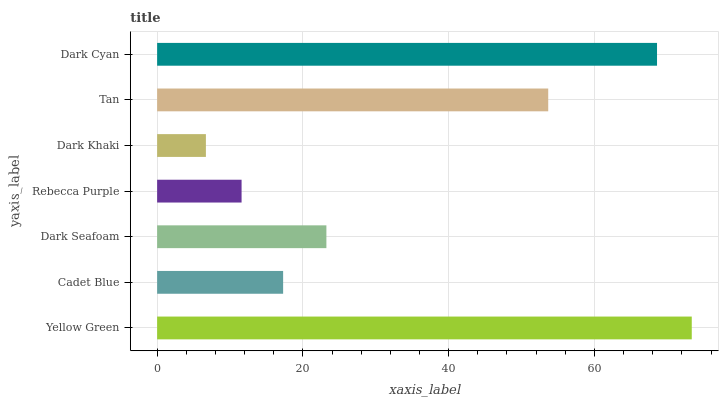Is Dark Khaki the minimum?
Answer yes or no. Yes. Is Yellow Green the maximum?
Answer yes or no. Yes. Is Cadet Blue the minimum?
Answer yes or no. No. Is Cadet Blue the maximum?
Answer yes or no. No. Is Yellow Green greater than Cadet Blue?
Answer yes or no. Yes. Is Cadet Blue less than Yellow Green?
Answer yes or no. Yes. Is Cadet Blue greater than Yellow Green?
Answer yes or no. No. Is Yellow Green less than Cadet Blue?
Answer yes or no. No. Is Dark Seafoam the high median?
Answer yes or no. Yes. Is Dark Seafoam the low median?
Answer yes or no. Yes. Is Rebecca Purple the high median?
Answer yes or no. No. Is Dark Cyan the low median?
Answer yes or no. No. 